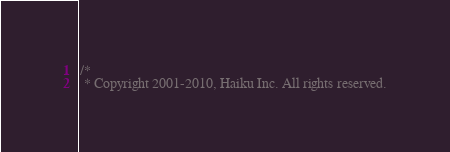Convert code to text. <code><loc_0><loc_0><loc_500><loc_500><_C_>/*
 * Copyright 2001-2010, Haiku Inc. All rights reserved.</code> 